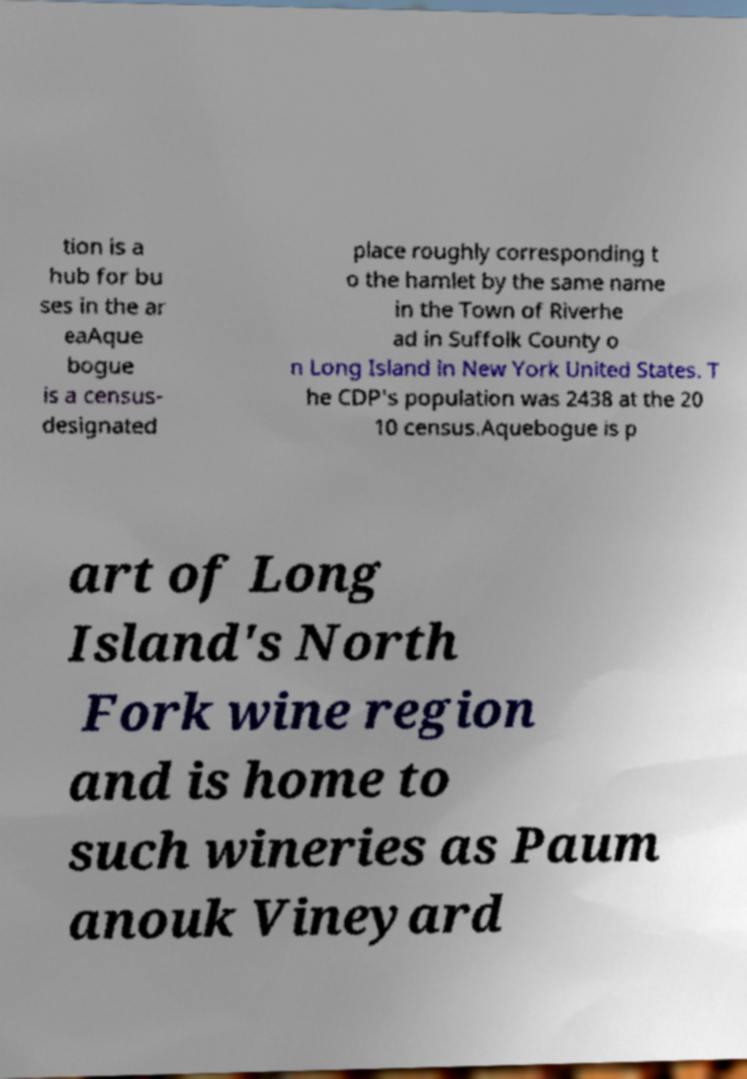There's text embedded in this image that I need extracted. Can you transcribe it verbatim? tion is a hub for bu ses in the ar eaAque bogue is a census- designated place roughly corresponding t o the hamlet by the same name in the Town of Riverhe ad in Suffolk County o n Long Island in New York United States. T he CDP's population was 2438 at the 20 10 census.Aquebogue is p art of Long Island's North Fork wine region and is home to such wineries as Paum anouk Vineyard 